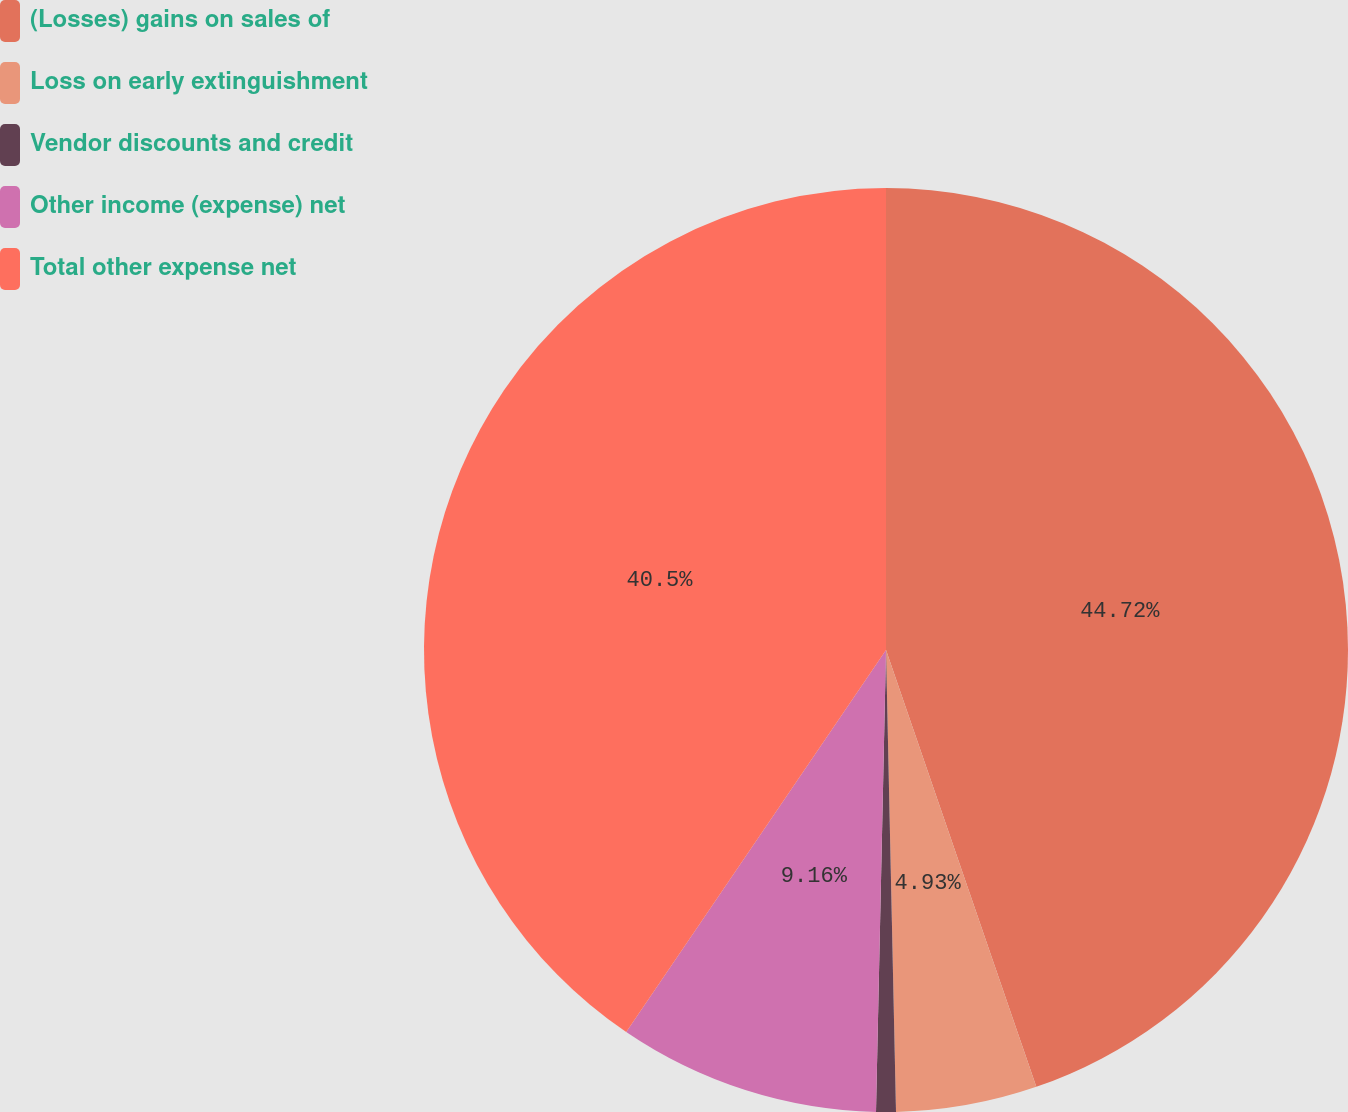<chart> <loc_0><loc_0><loc_500><loc_500><pie_chart><fcel>(Losses) gains on sales of<fcel>Loss on early extinguishment<fcel>Vendor discounts and credit<fcel>Other income (expense) net<fcel>Total other expense net<nl><fcel>44.73%<fcel>4.93%<fcel>0.69%<fcel>9.16%<fcel>40.5%<nl></chart> 